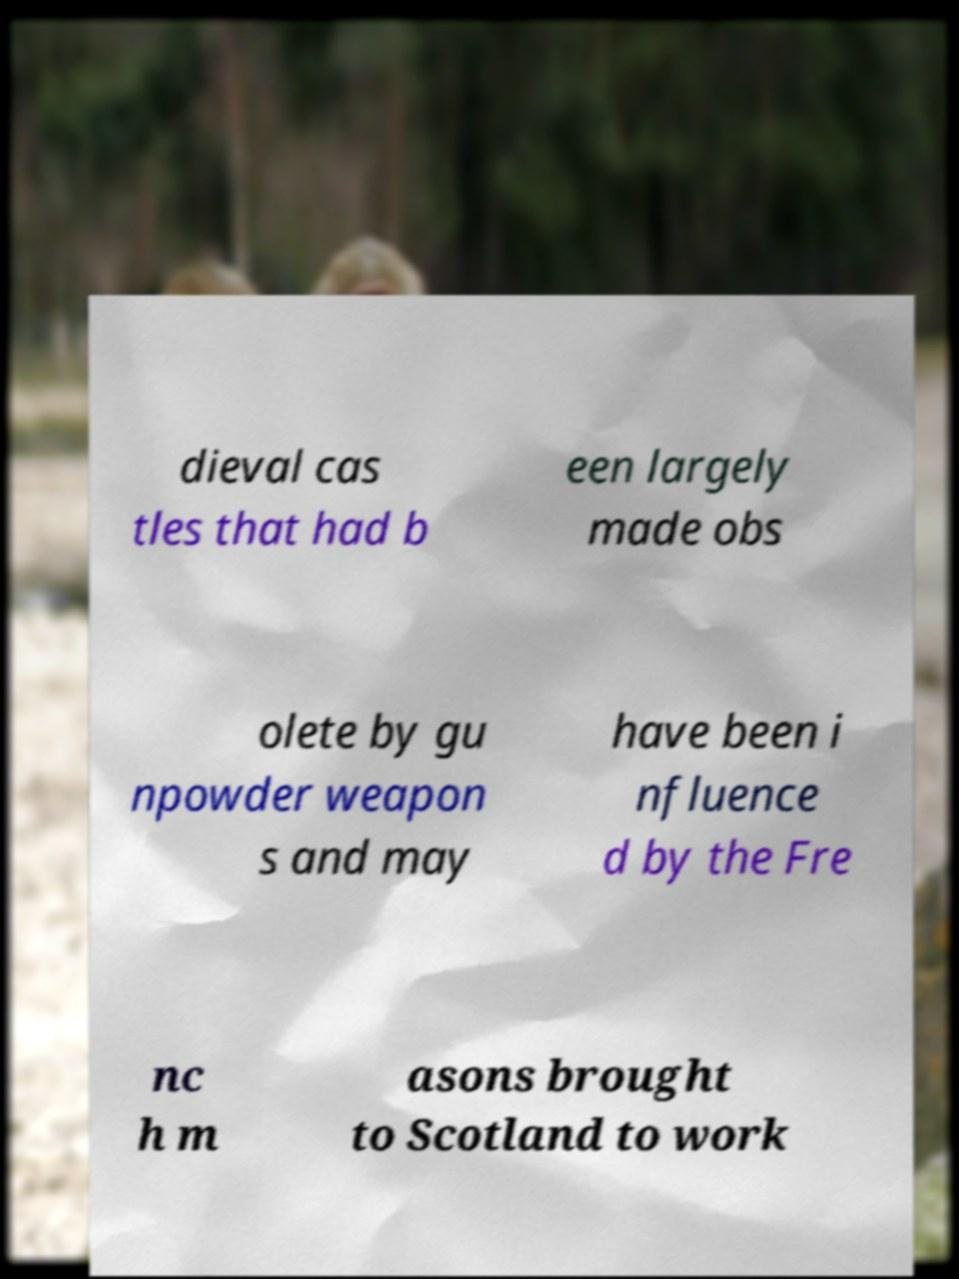Please identify and transcribe the text found in this image. dieval cas tles that had b een largely made obs olete by gu npowder weapon s and may have been i nfluence d by the Fre nc h m asons brought to Scotland to work 